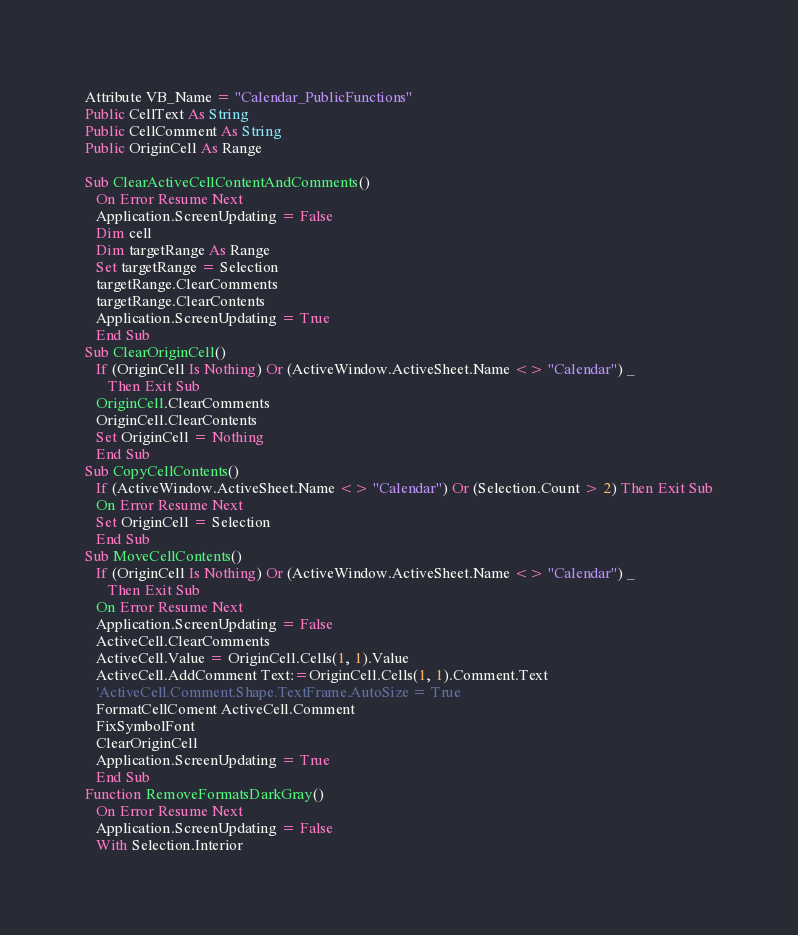<code> <loc_0><loc_0><loc_500><loc_500><_VisualBasic_>Attribute VB_Name = "Calendar_PublicFunctions"
Public CellText As String
Public CellComment As String
Public OriginCell As Range

Sub ClearActiveCellContentAndComments()
   On Error Resume Next
   Application.ScreenUpdating = False
   Dim cell
   Dim targetRange As Range
   Set targetRange = Selection
   targetRange.ClearComments
   targetRange.ClearContents
   Application.ScreenUpdating = True
   End Sub
Sub ClearOriginCell()
   If (OriginCell Is Nothing) Or (ActiveWindow.ActiveSheet.Name <> "Calendar") _
      Then Exit Sub
   OriginCell.ClearComments
   OriginCell.ClearContents
   Set OriginCell = Nothing
   End Sub
Sub CopyCellContents()
   If (ActiveWindow.ActiveSheet.Name <> "Calendar") Or (Selection.Count > 2) Then Exit Sub
   On Error Resume Next
   Set OriginCell = Selection
   End Sub
Sub MoveCellContents()
   If (OriginCell Is Nothing) Or (ActiveWindow.ActiveSheet.Name <> "Calendar") _
      Then Exit Sub
   On Error Resume Next
   Application.ScreenUpdating = False
   ActiveCell.ClearComments
   ActiveCell.Value = OriginCell.Cells(1, 1).Value
   ActiveCell.AddComment Text:=OriginCell.Cells(1, 1).Comment.Text
   'ActiveCell.Comment.Shape.TextFrame.AutoSize = True
   FormatCellComent ActiveCell.Comment
   FixSymbolFont
   ClearOriginCell
   Application.ScreenUpdating = True
   End Sub
Function RemoveFormatsDarkGray()
   On Error Resume Next
   Application.ScreenUpdating = False
   With Selection.Interior</code> 